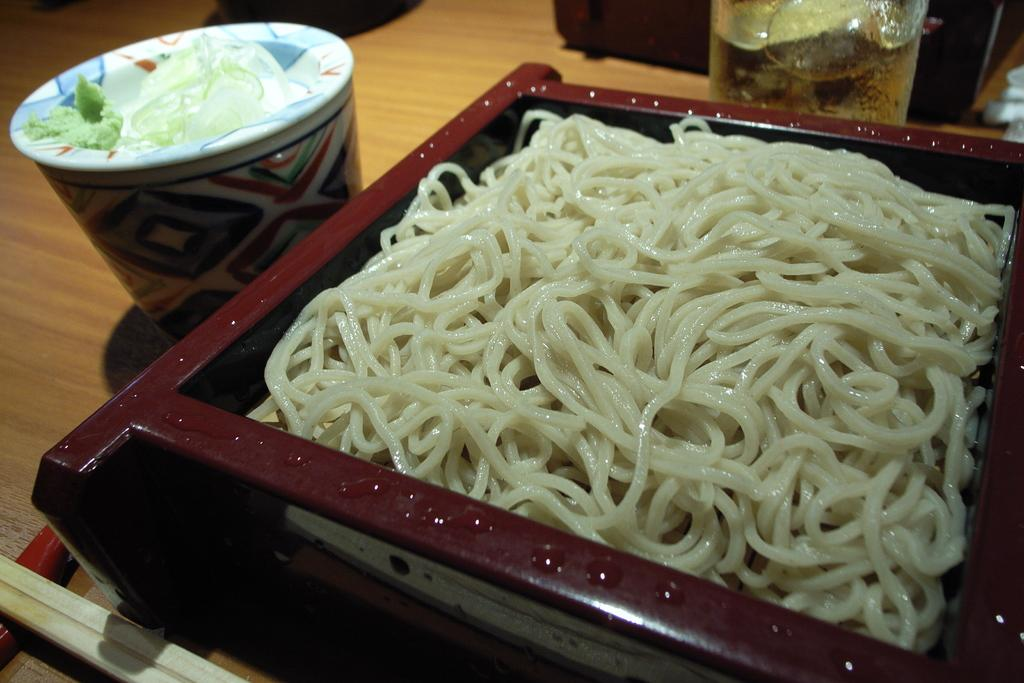What type of noodles are in the bowl in the image? There are white color noodles in the bowl. Where is the bowl located in the image? The bowl is placed on the right side of the image. What is the bowl placed on in the image? The bowl is placed on a wooden table. What other items can be seen on the wooden table? There is a cup and a glass on the wooden table, along with other objects. Is there a crown on the table in the image? No, there is no crown present in the image. Are the noodles in the bowl attacking the other objects on the table? No, the noodles are not attacking any objects in the image; they are stationary in the bowl. 